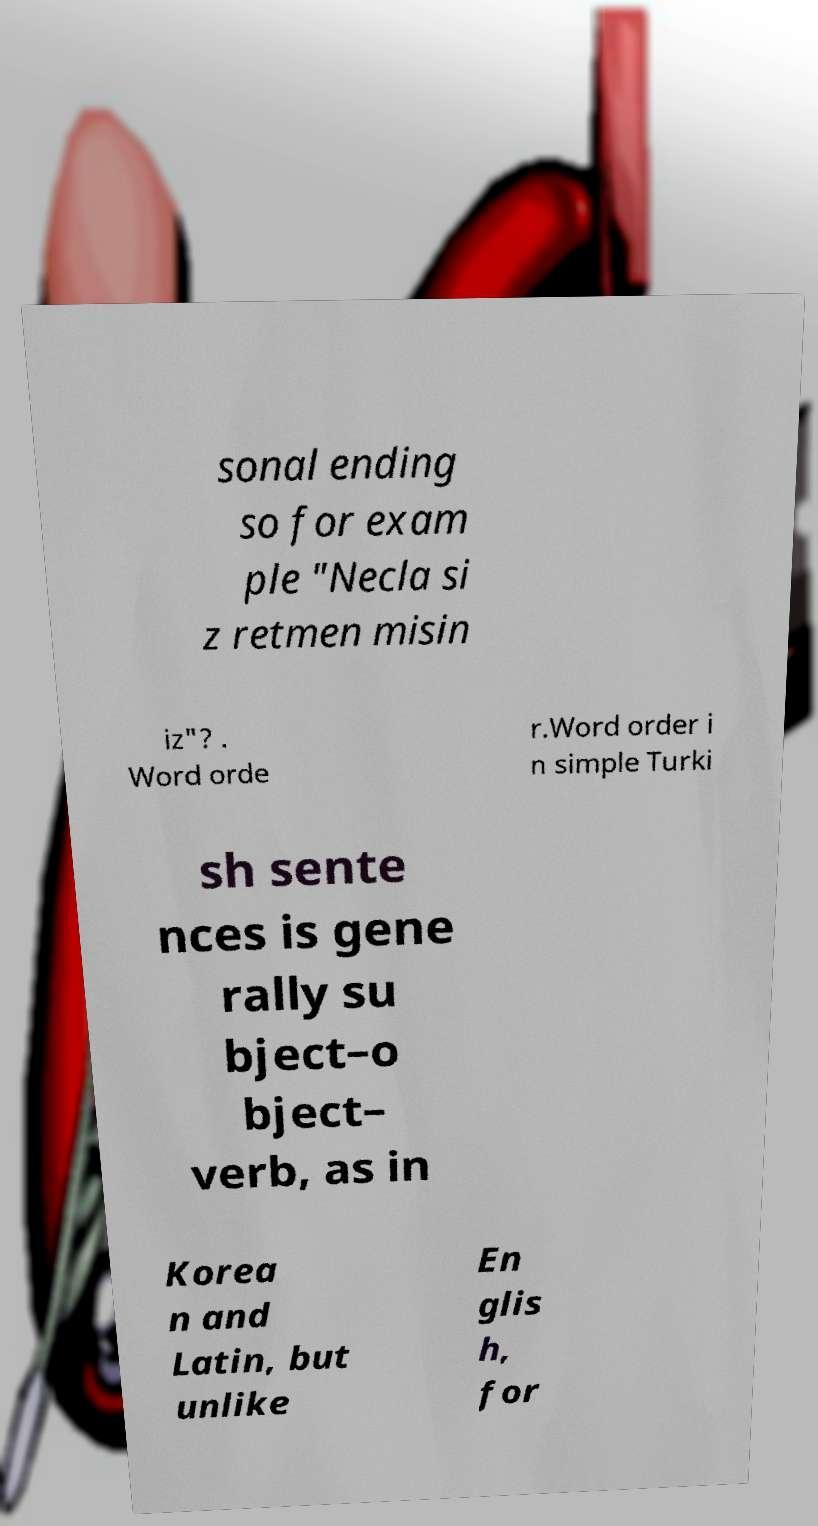What messages or text are displayed in this image? I need them in a readable, typed format. sonal ending so for exam ple "Necla si z retmen misin iz"? . Word orde r.Word order i n simple Turki sh sente nces is gene rally su bject–o bject– verb, as in Korea n and Latin, but unlike En glis h, for 